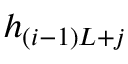<formula> <loc_0><loc_0><loc_500><loc_500>h _ { ( i - 1 ) L + j }</formula> 